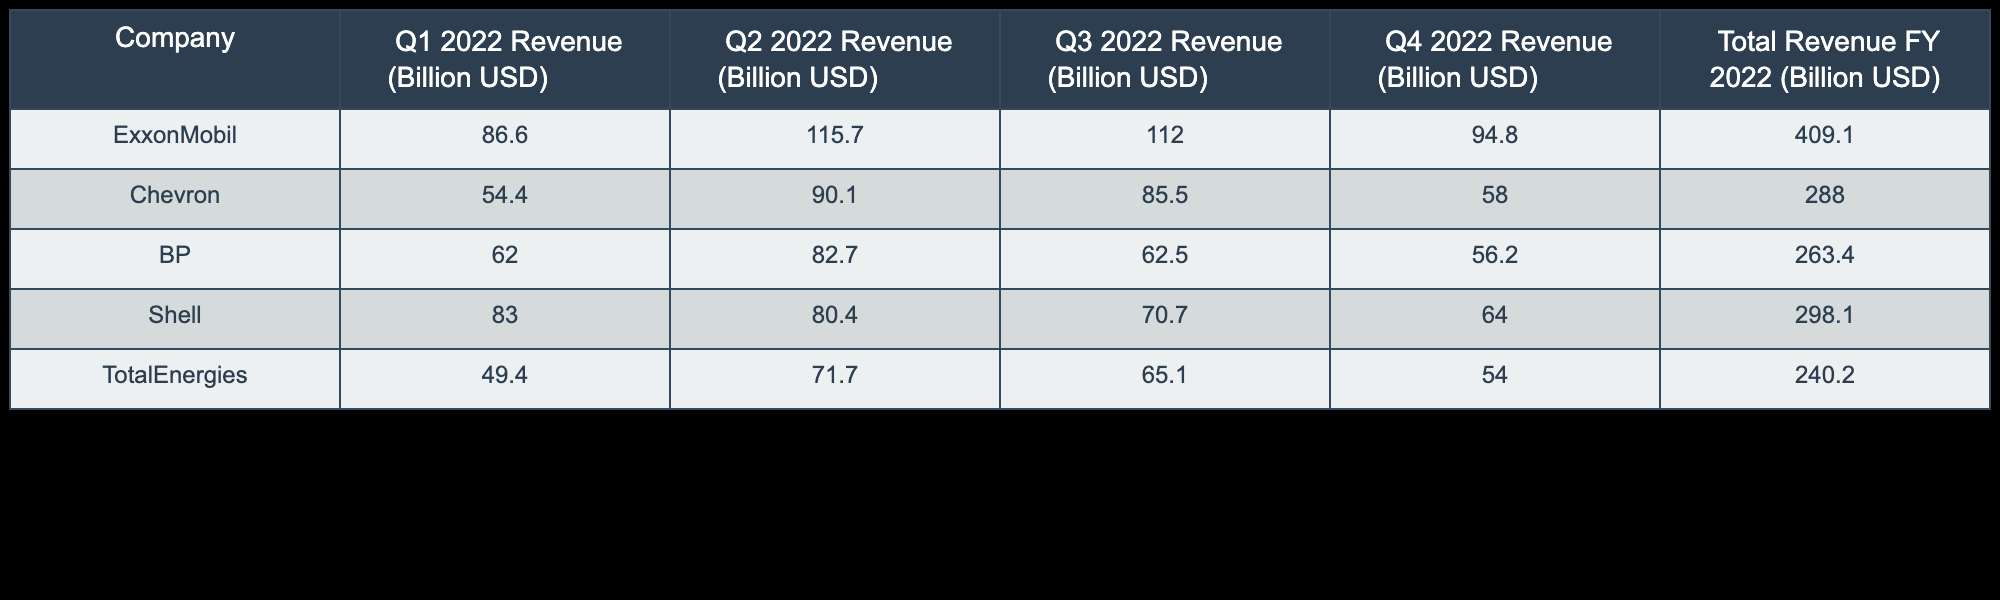What was the total revenue for ExxonMobil in FY 2022? The total revenue for ExxonMobil can be found in the last column of the table. It states that the total revenue for FY 2022 is 409.1 billion USD.
Answer: 409.1 billion USD Which company had the highest revenue in Q2 2022? Looking at the Q2 2022 column, ExxonMobil shows a revenue of 115.7 billion USD, which is higher than any other company listed in that column.
Answer: ExxonMobil What is the average quarterly revenue for Chevron in FY 2022? To find the average quarterly revenue, sum Chevron's quarterly revenues (54.4 + 90.1 + 85.5 + 58.0) = 288.0 billion USD, then divide by 4 (the number of quarters), resulting in 288.0 / 4 = 72.0 billion USD as the average.
Answer: 72.0 billion USD Did Shell earn more in Q3 2022 than BP? In Q3 2022, Shell's revenue is 70.7 billion USD, while BP's revenue is 62.5 billion USD. Since 70.7 is greater than 62.5, the answer is yes.
Answer: Yes What was the total revenue for TotalEnergies and BP combined in FY 2022? The total revenue for TotalEnergies is 240.2 billion USD and for BP is 263.4 billion USD. Adding these amounts gives 240.2 + 263.4 = 503.6 billion USD for both companies combined.
Answer: 503.6 billion USD Which company had the lowest total revenue in FY 2022? By comparing the total revenue figures across all companies, TotalEnergies has the lowest total revenue at 240.2 billion USD in FY 2022.
Answer: TotalEnergies What was ExxonMobil's revenue decline from Q1 to Q4 2022? To find the decline from Q1 to Q4, subtract the Q4 revenue (94.8 billion USD) from the Q1 revenue (86.6 billion USD), resulting in a decline of 86.6 - 94.8 = -8.2 billion USD, indicating an increase, not a decline.
Answer: -8.2 billion USD What percentage of the total revenue for Shell in FY 2022 was generated during Q1? Shell's Q1 revenue is 83.0 billion USD and its total revenue is 298.1 billion USD. The percentage is calculated as (83.0 / 298.1) * 100, resulting in approximately 27.8%.
Answer: 27.8% Was the total Q3 revenue lower than Q4 revenue for all companies combined? The total Q3 revenues are 112.0 (ExxonMobil) + 85.5 (Chevron) + 62.5 (BP) + 70.7 (Shell) + 65.1 (TotalEnergies) = 396.8 billion USD. The total Q4 revenues are 94.8 (ExxonMobil) + 58.0 (Chevron) + 56.2 (BP) + 64.0 (Shell) + 54.0 (TotalEnergies) = 327.0 billion USD. Since 396.8 is greater than 327.0, the answer is no.
Answer: No 